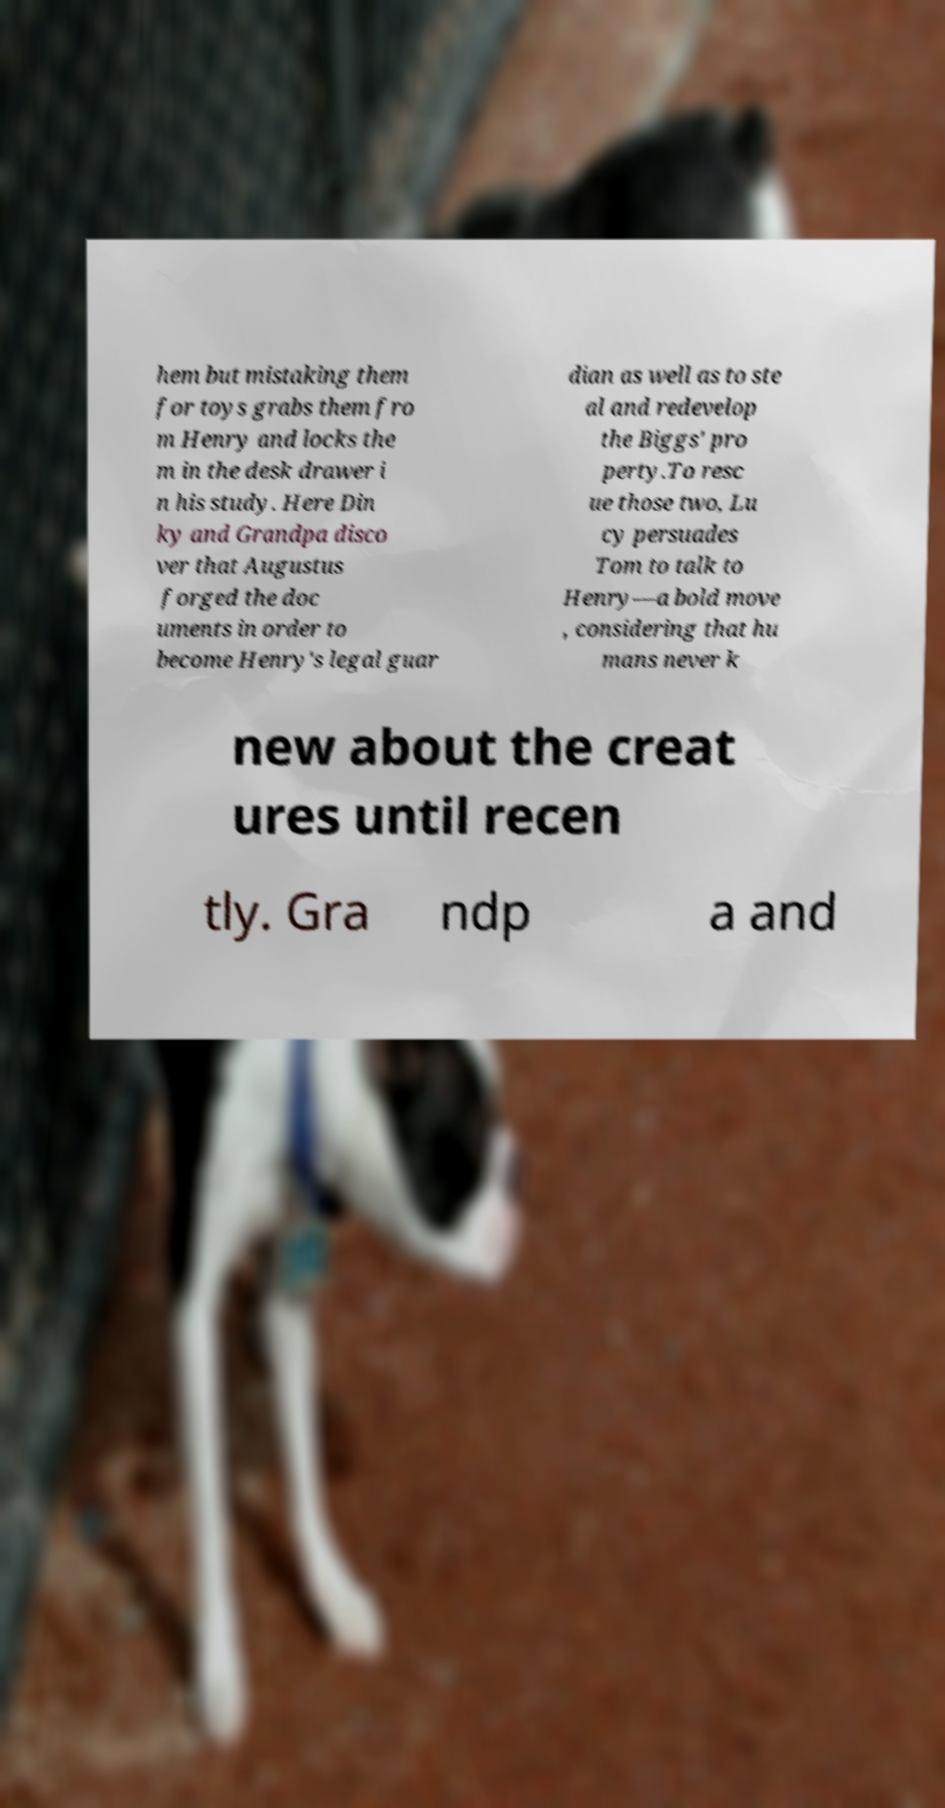For documentation purposes, I need the text within this image transcribed. Could you provide that? hem but mistaking them for toys grabs them fro m Henry and locks the m in the desk drawer i n his study. Here Din ky and Grandpa disco ver that Augustus forged the doc uments in order to become Henry's legal guar dian as well as to ste al and redevelop the Biggs' pro perty.To resc ue those two, Lu cy persuades Tom to talk to Henry—a bold move , considering that hu mans never k new about the creat ures until recen tly. Gra ndp a and 